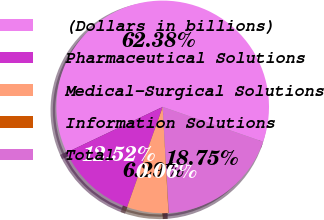<chart> <loc_0><loc_0><loc_500><loc_500><pie_chart><fcel>(Dollars in billions)<fcel>Pharmaceutical Solutions<fcel>Medical-Surgical Solutions<fcel>Information Solutions<fcel>Total<nl><fcel>62.37%<fcel>12.52%<fcel>6.29%<fcel>0.06%<fcel>18.75%<nl></chart> 